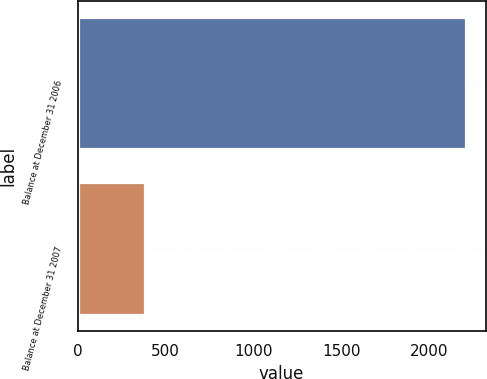Convert chart to OTSL. <chart><loc_0><loc_0><loc_500><loc_500><bar_chart><fcel>Balance at December 31 2006<fcel>Balance at December 31 2007<nl><fcel>2208<fcel>386<nl></chart> 